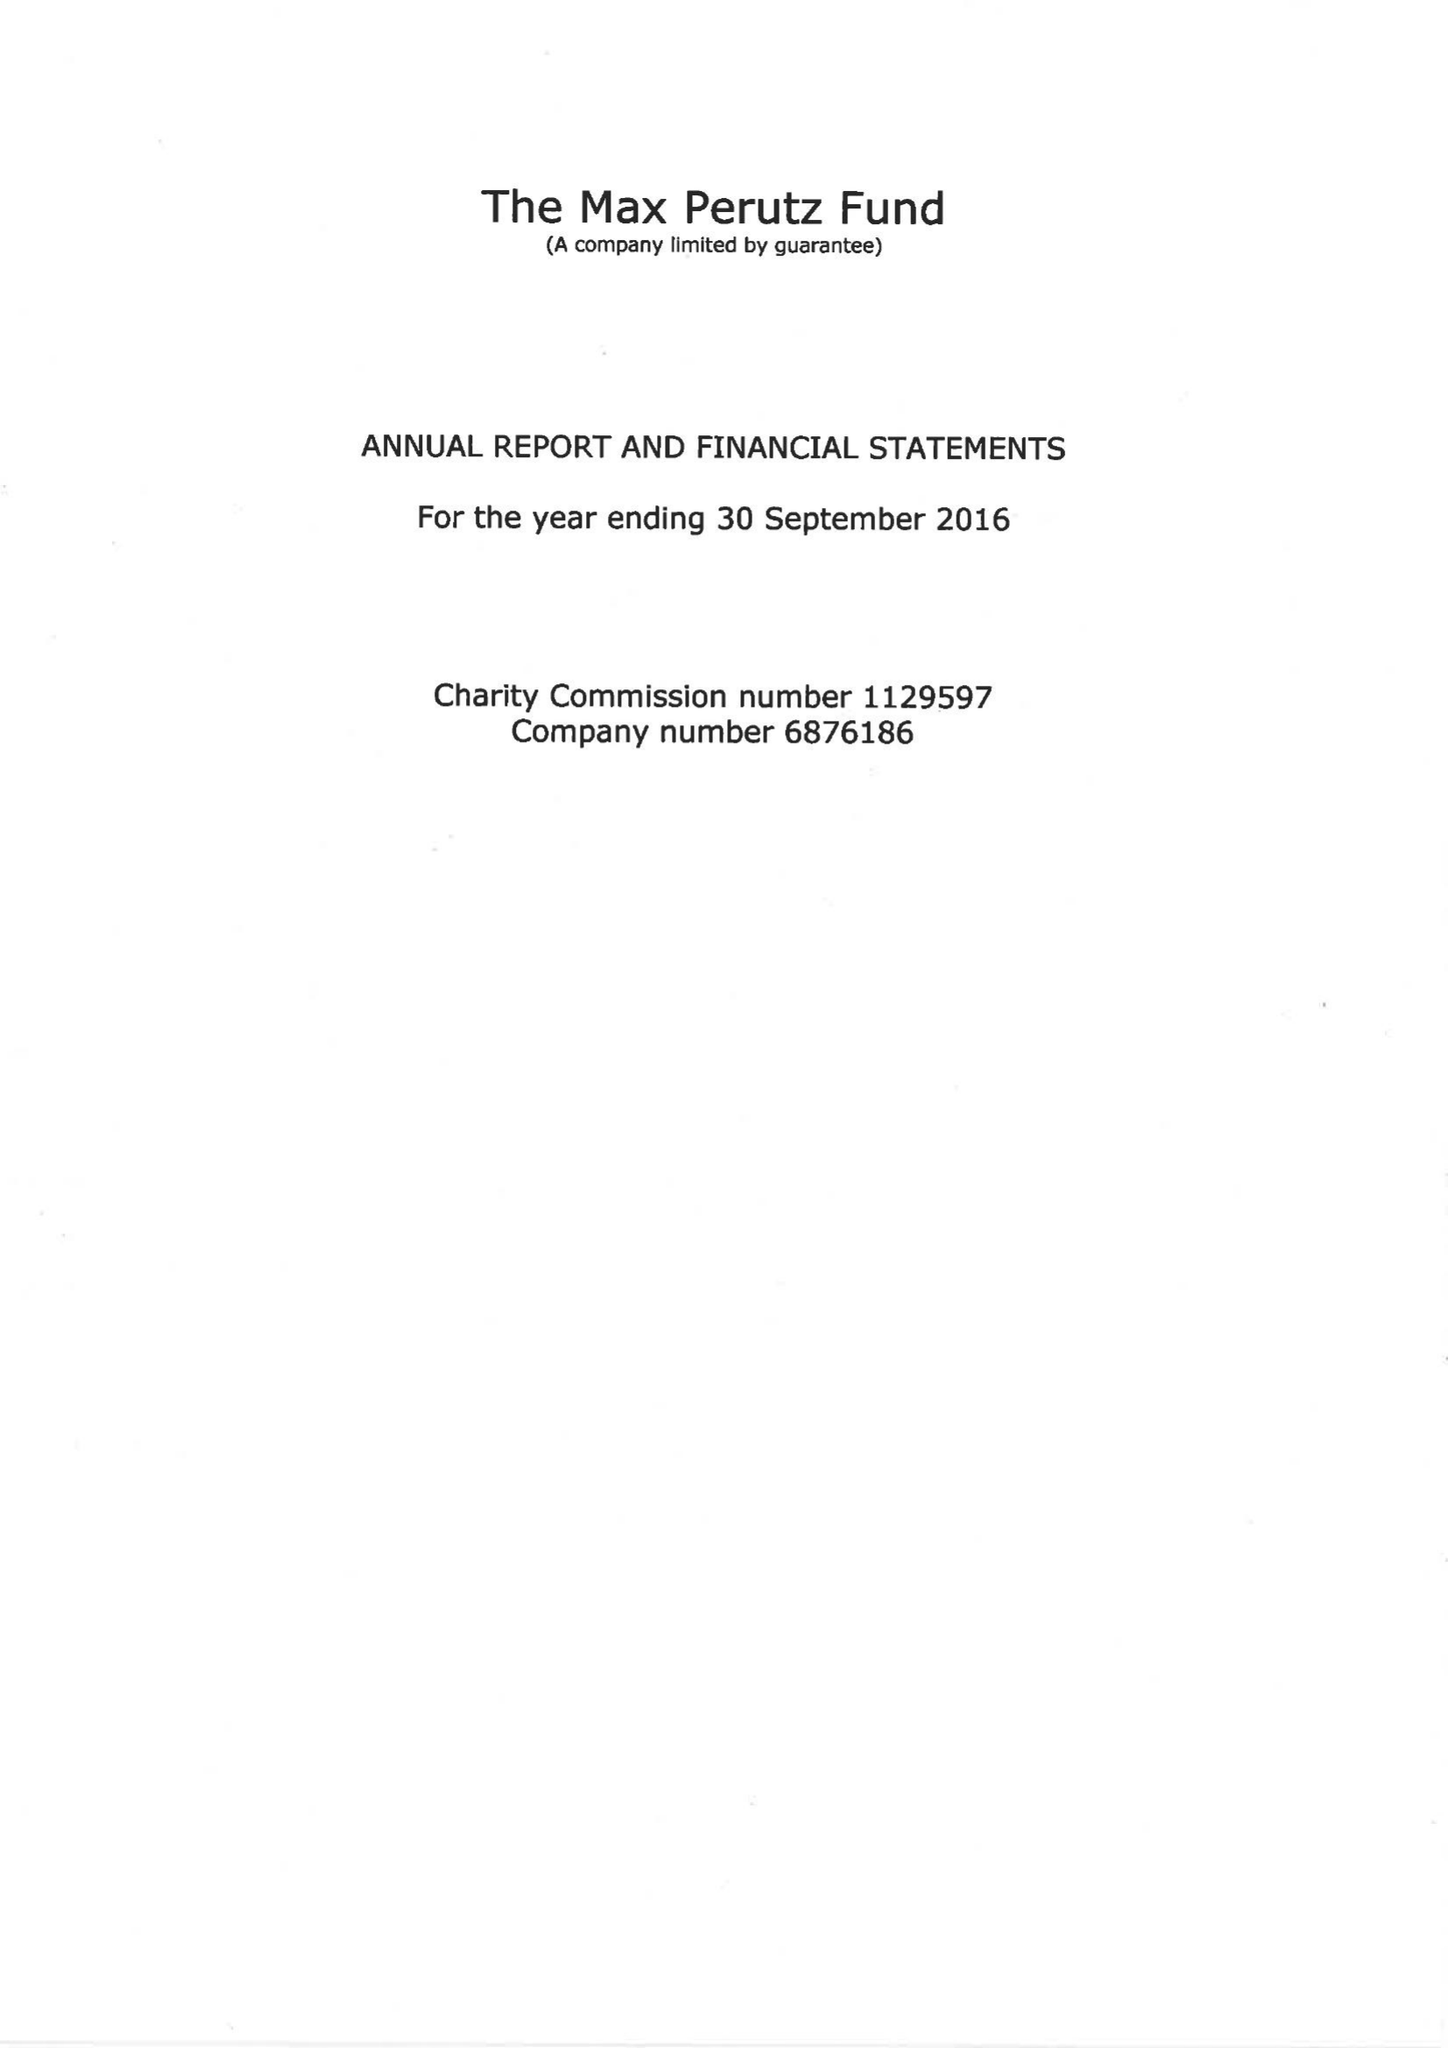What is the value for the report_date?
Answer the question using a single word or phrase. 2016-09-30 